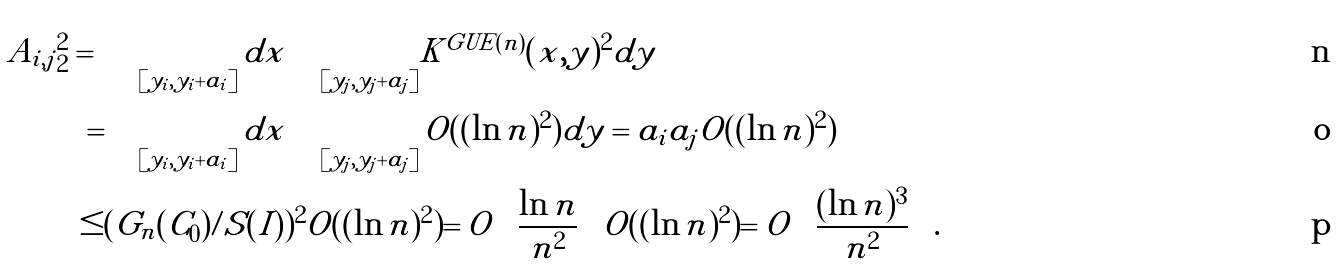<formula> <loc_0><loc_0><loc_500><loc_500>| A _ { i , j } | _ { 2 } ^ { 2 } = & \int _ { [ y _ { i } , y _ { i } + a _ { i } ] } d x \int _ { [ y _ { j } , y _ { j } + a _ { j } ] } | K ^ { G U E ( n ) } ( x , y ) | ^ { 2 } d y \\ = & \int _ { [ y _ { i } , y _ { i } + a _ { i } ] } d x \int _ { [ y _ { j } , y _ { j } + a _ { j } ] } O ( ( \ln n ) ^ { 2 } ) d y = a _ { i } a _ { j } O ( ( \ln n ) ^ { 2 } ) \\ \leq & ( G _ { n } ( C _ { 0 } ) / S ( I ) ) ^ { 2 } O ( ( \ln n ) ^ { 2 } ) = O \left ( \frac { \ln n } { n ^ { 2 } } \right ) O ( ( \ln n ) ^ { 2 } ) = O \left ( \frac { ( \ln n ) ^ { 3 } } { n ^ { 2 } } \right ) .</formula> 